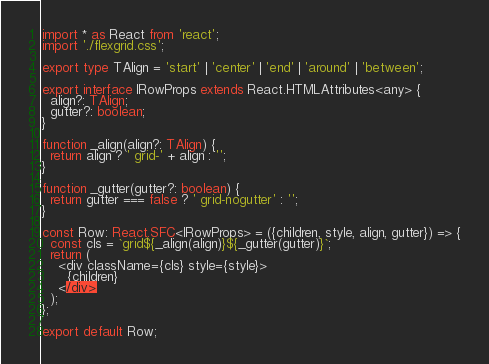Convert code to text. <code><loc_0><loc_0><loc_500><loc_500><_TypeScript_>import * as React from 'react';
import './flexgrid.css';

export type TAlign = 'start' | 'center' | 'end' | 'around' | 'between';

export interface IRowProps extends React.HTMLAttributes<any> {
  align?: TAlign;
  gutter?: boolean;
}

function _align(align?: TAlign) {
  return align ? ' grid-' + align : '';
}

function _gutter(gutter?: boolean) {
  return gutter === false ? ' grid-nogutter' : '';
}

const Row: React.SFC<IRowProps> = ({children, style, align, gutter}) => {
  const cls = `grid${_align(align)}${_gutter(gutter)}`;
  return (
    <div className={cls} style={style}>
      {children}
    </div>
  );
};

export default Row;
</code> 